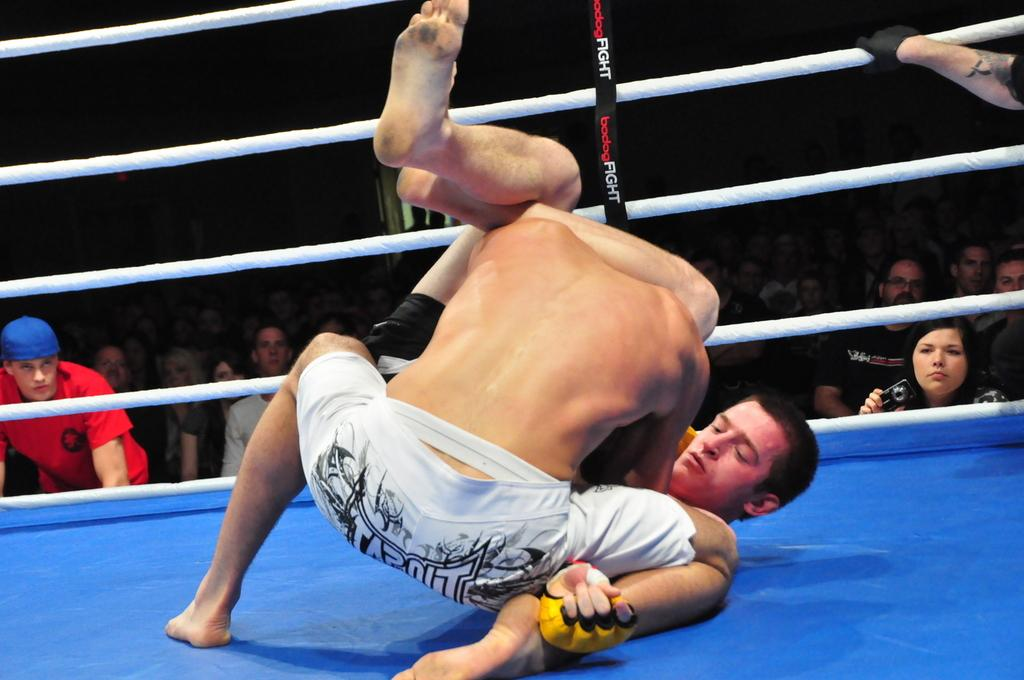How many people are involved in the main activity in the image? There are two persons in the image. What are the two persons doing in the image? The two persons are fighting in the image. Where is the fighting taking place? The fighting is taking place in a boxing court. Are there any spectators in the image? Yes, there are people sitting behind the fighters, watching the event. How many beds are visible in the image? There are no beds visible in the image. What type of club is being used by the fighters in the image? There is no club present in the image; the fighters are boxing, not using a club. 